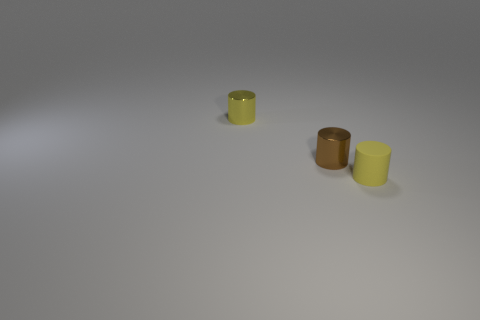Subtract all tiny yellow rubber cylinders. How many cylinders are left? 2 Add 1 large cyan cubes. How many objects exist? 4 Subtract all yellow cylinders. How many cylinders are left? 1 Subtract all cyan cubes. How many yellow cylinders are left? 2 Subtract 1 cylinders. How many cylinders are left? 2 Add 2 small brown cylinders. How many small brown cylinders are left? 3 Add 2 purple metal balls. How many purple metal balls exist? 2 Subtract 0 yellow cubes. How many objects are left? 3 Subtract all yellow cylinders. Subtract all gray blocks. How many cylinders are left? 1 Subtract all matte things. Subtract all brown cylinders. How many objects are left? 1 